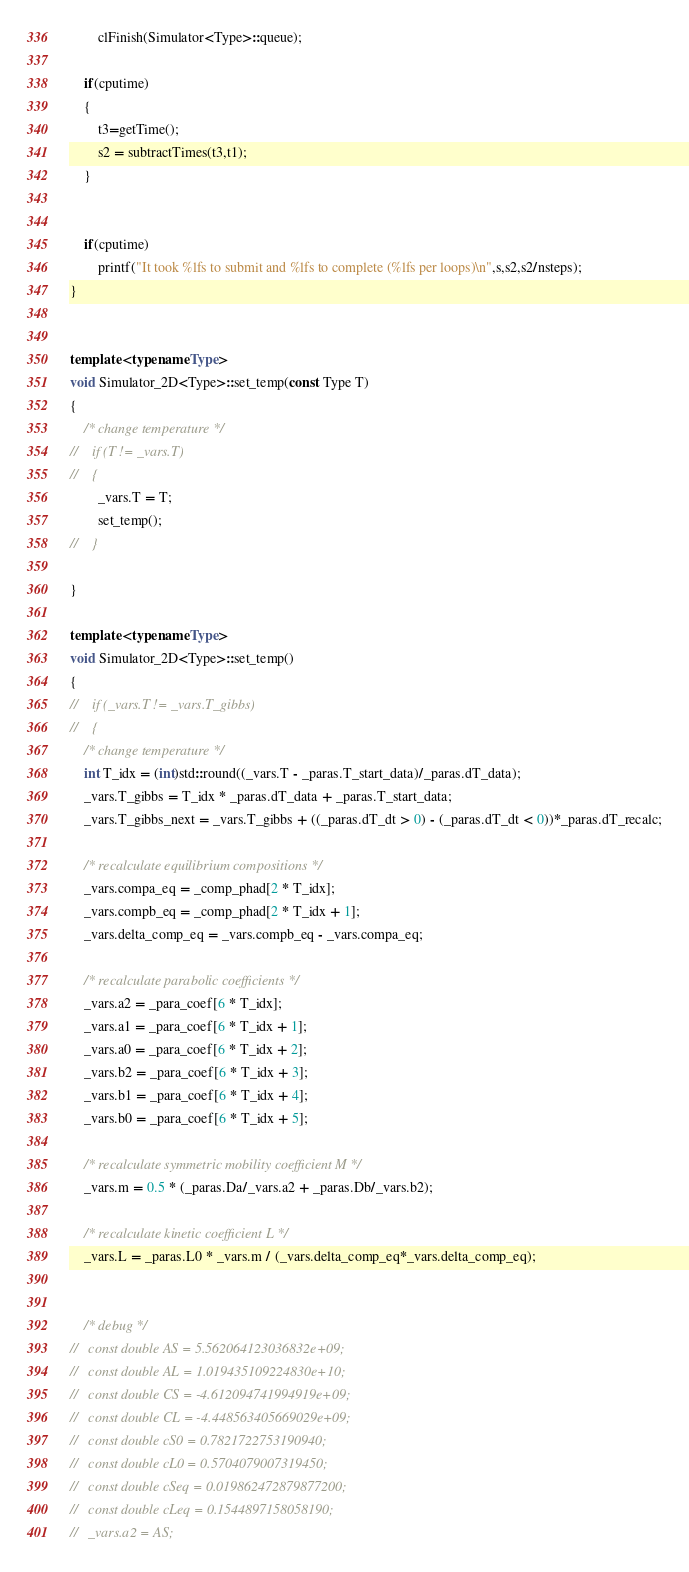<code> <loc_0><loc_0><loc_500><loc_500><_C++_>        clFinish(Simulator<Type>::queue);
    
    if(cputime)
    {
        t3=getTime();
        s2 = subtractTimes(t3,t1);
    }
    
    
    if(cputime)
        printf("It took %lfs to submit and %lfs to complete (%lfs per loops)\n",s,s2,s2/nsteps);
}


template <typename Type>
void Simulator_2D<Type>::set_temp(const Type T)
{
    /* change temperature */
//    if (T != _vars.T)
//    {
        _vars.T = T;
        set_temp();
//    }
    
}

template <typename Type>
void Simulator_2D<Type>::set_temp()
{
//    if (_vars.T != _vars.T_gibbs)
//    {
    /* change temperature */
    int T_idx = (int)std::round((_vars.T - _paras.T_start_data)/_paras.dT_data);
    _vars.T_gibbs = T_idx * _paras.dT_data + _paras.T_start_data;
    _vars.T_gibbs_next = _vars.T_gibbs + ((_paras.dT_dt > 0) - (_paras.dT_dt < 0))*_paras.dT_recalc;
    
    /* recalculate equilibrium compositions */
    _vars.compa_eq = _comp_phad[2 * T_idx];
    _vars.compb_eq = _comp_phad[2 * T_idx + 1];
    _vars.delta_comp_eq = _vars.compb_eq - _vars.compa_eq;
    
    /* recalculate parabolic coefficients */
    _vars.a2 = _para_coef[6 * T_idx];
    _vars.a1 = _para_coef[6 * T_idx + 1];
    _vars.a0 = _para_coef[6 * T_idx + 2];
    _vars.b2 = _para_coef[6 * T_idx + 3];
    _vars.b1 = _para_coef[6 * T_idx + 4];
    _vars.b0 = _para_coef[6 * T_idx + 5];

    /* recalculate symmetric mobility coefficient M */
    _vars.m = 0.5 * (_paras.Da/_vars.a2 + _paras.Db/_vars.b2);
    
    /* recalculate kinetic coefficient L */
    _vars.L = _paras.L0 * _vars.m / (_vars.delta_comp_eq*_vars.delta_comp_eq);
    

    /* debug */
//   const double AS = 5.562064123036832e+09;
//   const double AL = 1.019435109224830e+10;
//   const double CS = -4.612094741994919e+09;
//   const double CL = -4.448563405669029e+09;
//   const double cS0 = 0.7821722753190940;
//   const double cL0 = 0.5704079007319450;
//   const double cSeq = 0.019862472879877200;
//   const double cLeq = 0.1544897158058190;
//   _vars.a2 = AS;</code> 